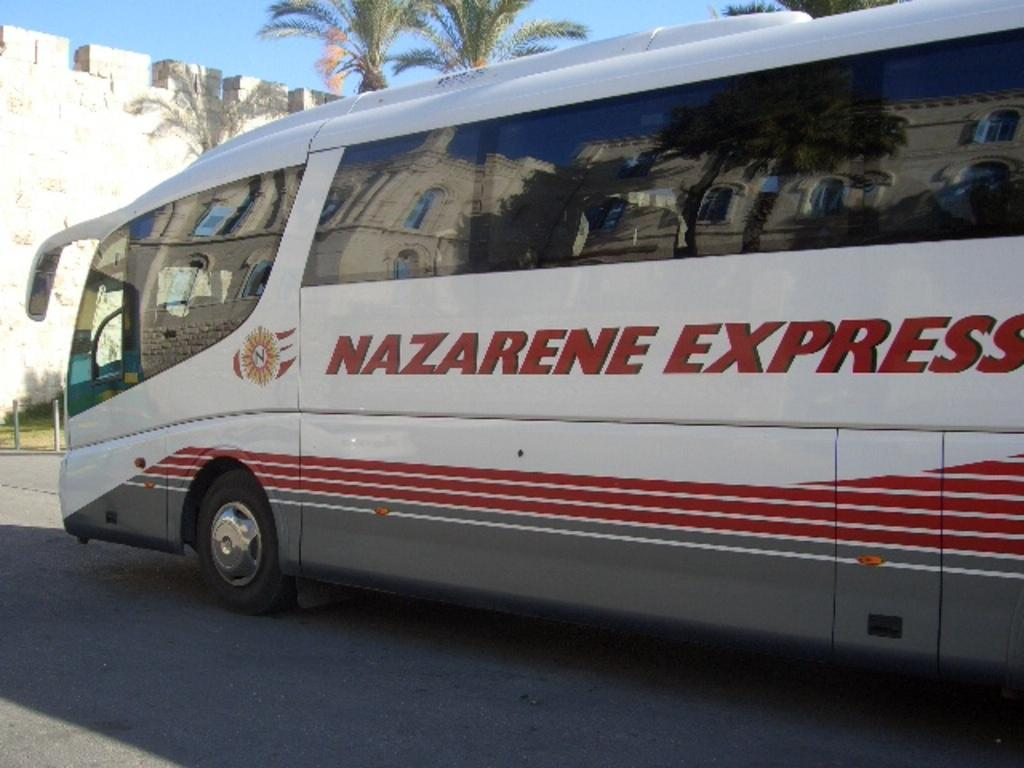<image>
Offer a succinct explanation of the picture presented. The bus has the word Nazarene Express on it's side 